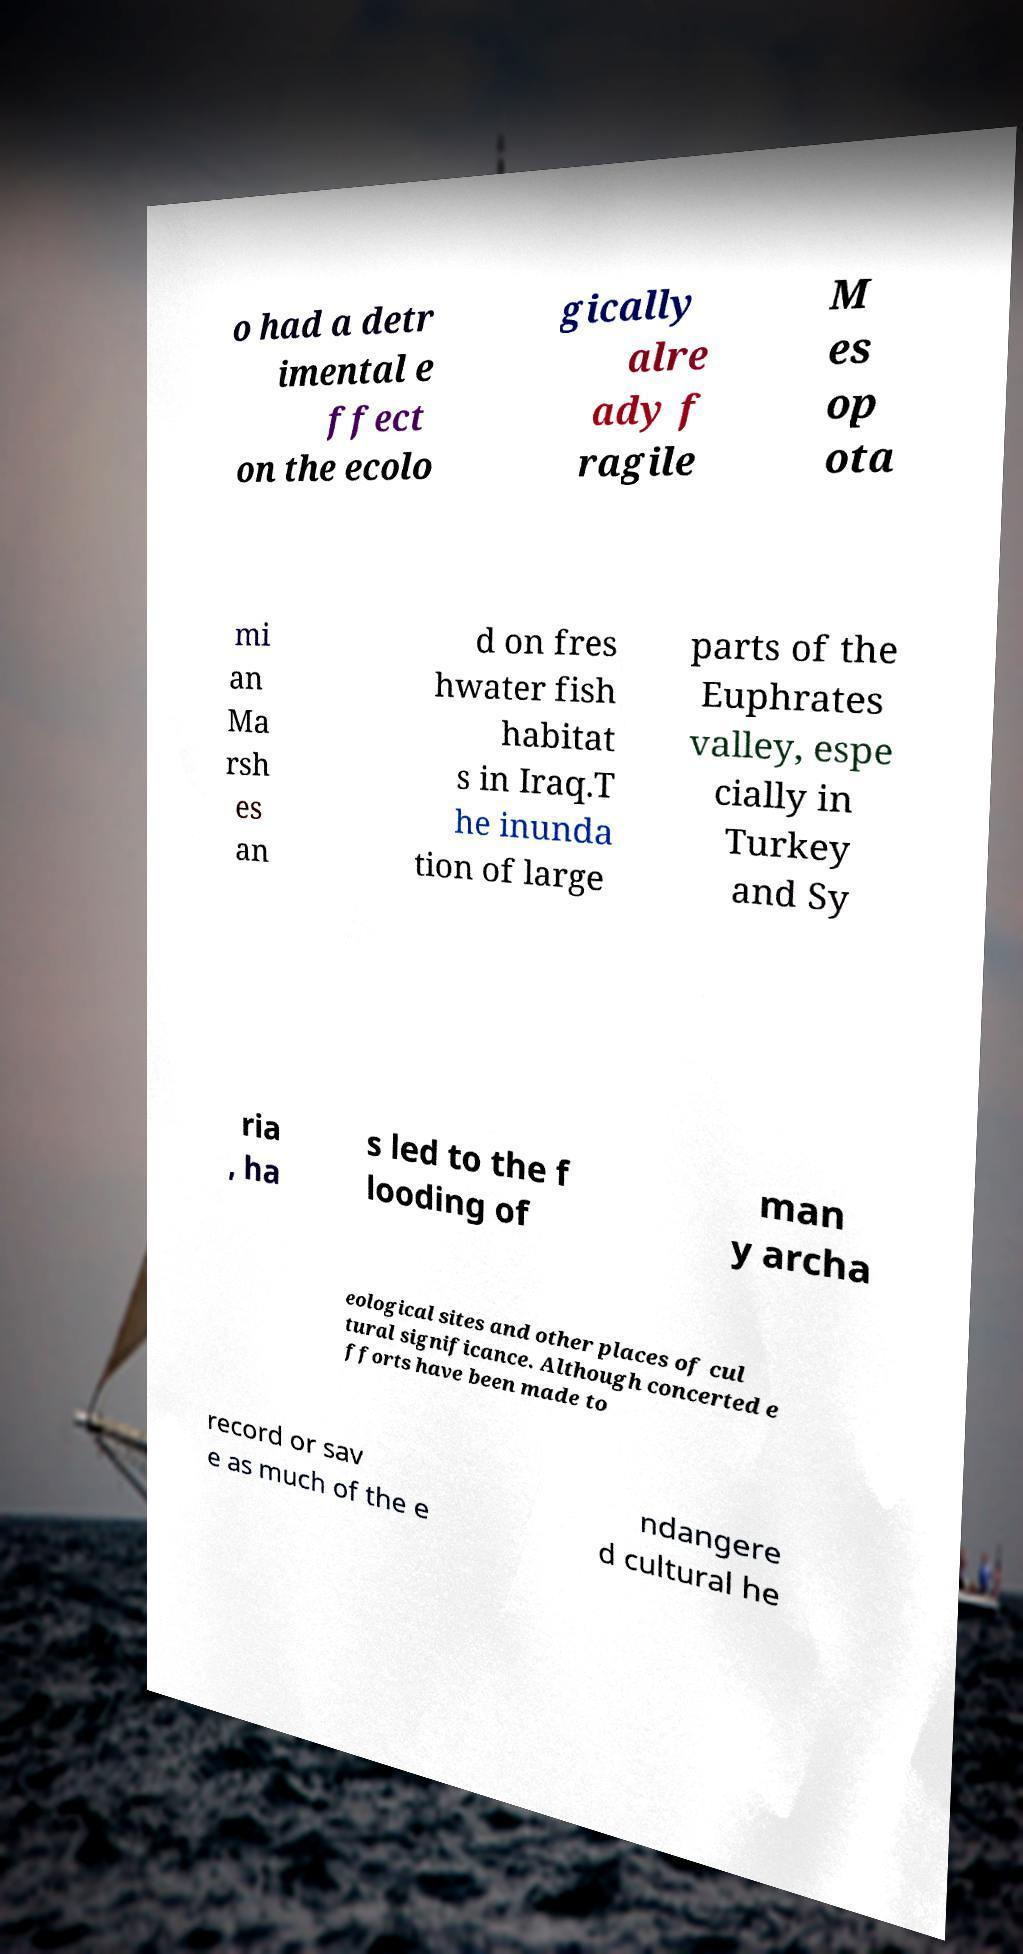Please identify and transcribe the text found in this image. o had a detr imental e ffect on the ecolo gically alre ady f ragile M es op ota mi an Ma rsh es an d on fres hwater fish habitat s in Iraq.T he inunda tion of large parts of the Euphrates valley, espe cially in Turkey and Sy ria , ha s led to the f looding of man y archa eological sites and other places of cul tural significance. Although concerted e fforts have been made to record or sav e as much of the e ndangere d cultural he 